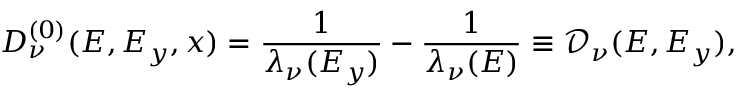Convert formula to latex. <formula><loc_0><loc_0><loc_500><loc_500>D _ { \nu } ^ { ( 0 ) } ( E , E _ { y } , x ) = \frac { 1 } { \lambda _ { \nu } ( E _ { y } ) } - \frac { 1 } { \lambda _ { \nu } ( E ) } \equiv \mathcal { D } _ { \nu } ( E , E _ { y } ) ,</formula> 